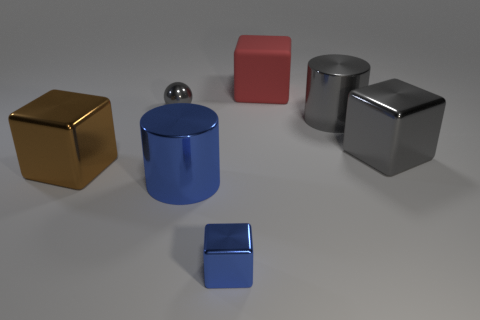There is a large cylinder that is behind the brown thing; does it have the same color as the small thing that is left of the small blue metal thing?
Your answer should be very brief. Yes. What material is the tiny thing that is left of the small blue metal block?
Provide a succinct answer. Metal. There is a tiny thing that is the same material as the tiny gray sphere; what color is it?
Provide a succinct answer. Blue. What number of gray cubes have the same size as the red block?
Make the answer very short. 1. There is a gray thing to the left of the blue cube; does it have the same size as the tiny blue block?
Give a very brief answer. Yes. The big object that is in front of the red thing and behind the gray cube has what shape?
Keep it short and to the point. Cylinder. Are there any big cubes on the left side of the red cube?
Offer a very short reply. Yes. Is there anything else that has the same shape as the large brown metal thing?
Provide a short and direct response. Yes. Is the small blue thing the same shape as the large brown thing?
Give a very brief answer. Yes. Are there the same number of cubes behind the small gray shiny ball and brown metal things behind the red matte block?
Offer a very short reply. No. 